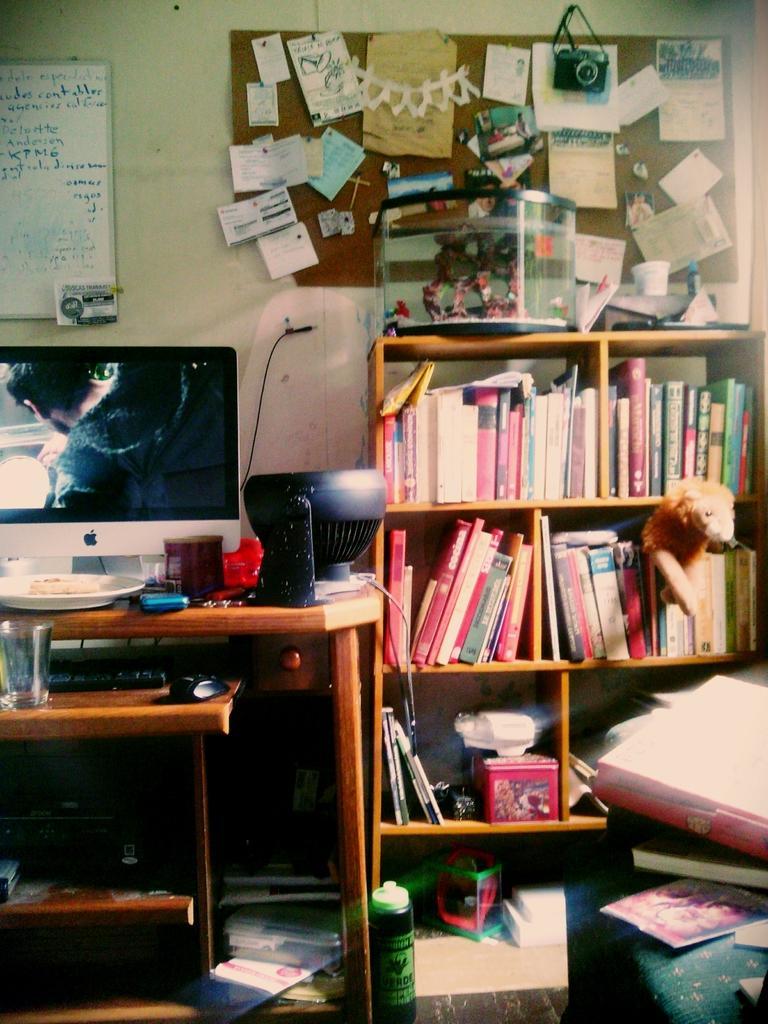Could you give a brief overview of what you see in this image? In the background we can see the boards, some paper notes, a device and the wall. We can see the books arranged in the racks and some objects. On the left side of the picture we can see a screen, food , plate, glass, keyboard, mouse and few objects placed on the tables. At the bottom portion of the picture we can see a bottle and few objects. On the right side of the picture we can see few objects. 